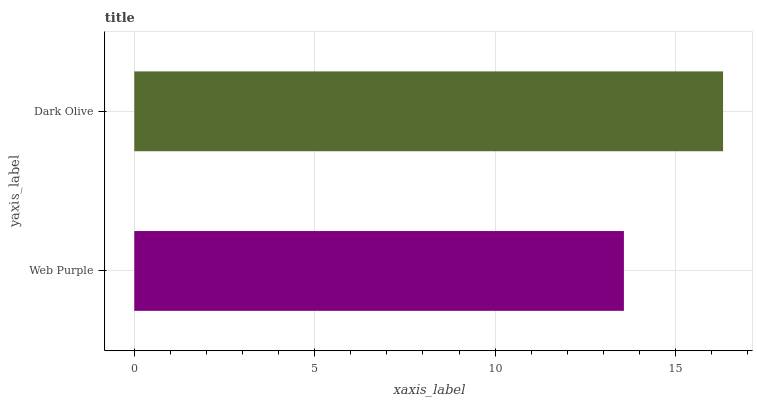Is Web Purple the minimum?
Answer yes or no. Yes. Is Dark Olive the maximum?
Answer yes or no. Yes. Is Dark Olive the minimum?
Answer yes or no. No. Is Dark Olive greater than Web Purple?
Answer yes or no. Yes. Is Web Purple less than Dark Olive?
Answer yes or no. Yes. Is Web Purple greater than Dark Olive?
Answer yes or no. No. Is Dark Olive less than Web Purple?
Answer yes or no. No. Is Dark Olive the high median?
Answer yes or no. Yes. Is Web Purple the low median?
Answer yes or no. Yes. Is Web Purple the high median?
Answer yes or no. No. Is Dark Olive the low median?
Answer yes or no. No. 